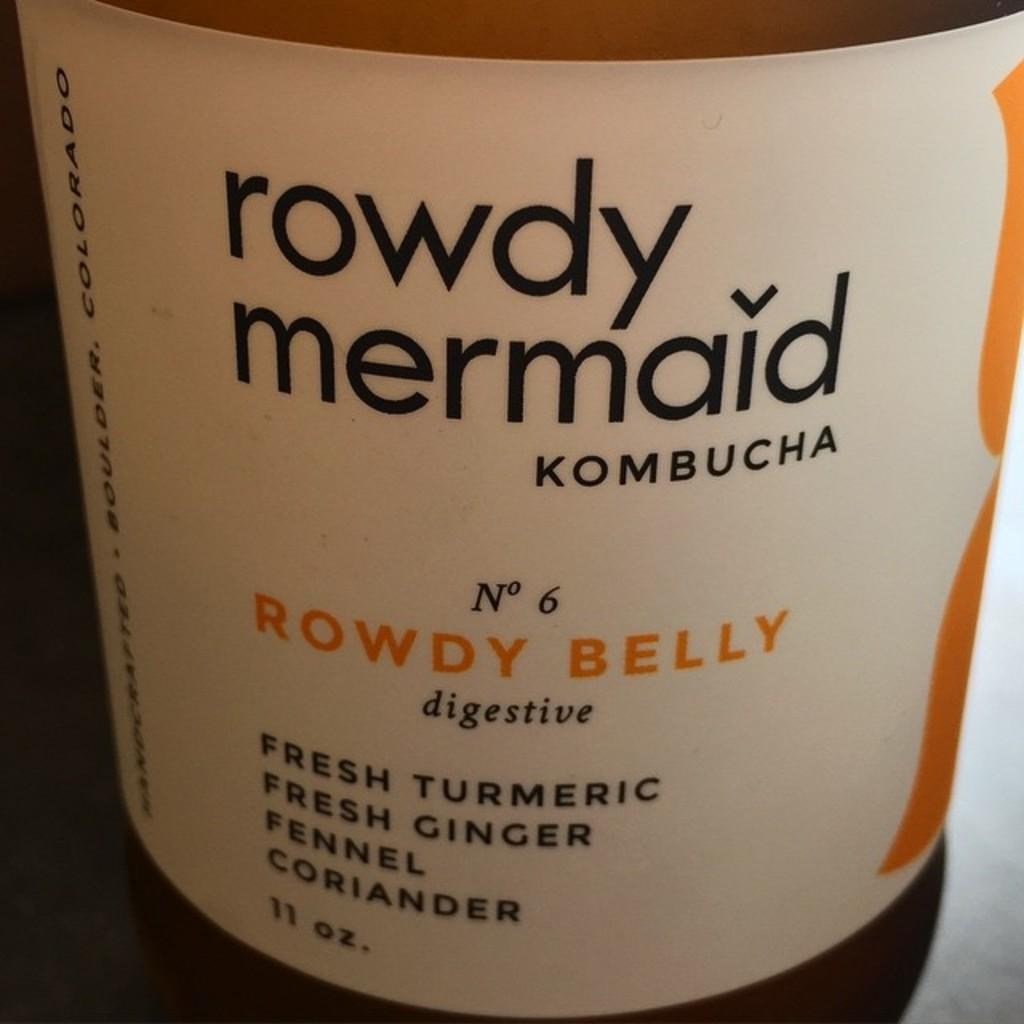<image>
Describe the image concisely. A label of kombucha called rowdy belly is shown up close. 